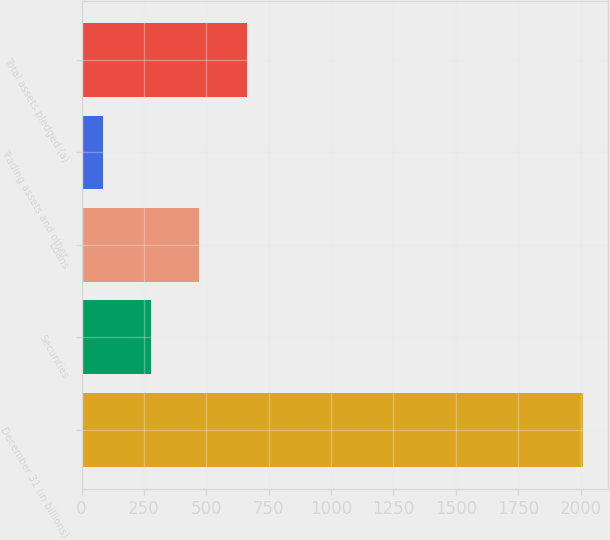<chart> <loc_0><loc_0><loc_500><loc_500><bar_chart><fcel>December 31 (in billions)<fcel>Securities<fcel>Loans<fcel>Trading assets and other<fcel>Total assets pledged (a)<nl><fcel>2009<fcel>277.04<fcel>469.48<fcel>84.6<fcel>661.92<nl></chart> 